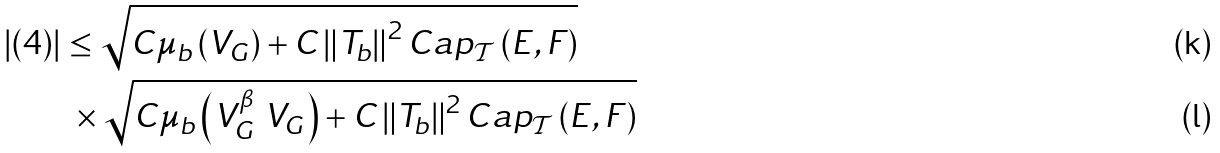<formula> <loc_0><loc_0><loc_500><loc_500>\left | ( 4 ) \right | & \leq \sqrt { C \mu _ { b } \left ( V _ { G } \right ) + C \left \| T _ { b } \right \| ^ { 2 } C a p _ { \mathcal { T } } \left ( E , F \right ) } \\ & \text { } \times \sqrt { C \mu _ { b } \left ( V _ { G } ^ { \beta } \ V _ { G } \right ) + C \left \| T _ { b } \right \| ^ { 2 } C a p _ { \mathcal { T } } \left ( E , F \right ) }</formula> 